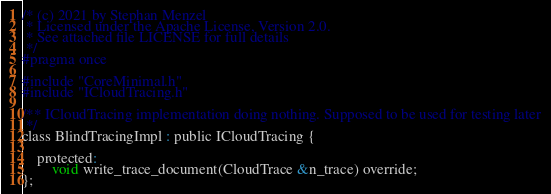Convert code to text. <code><loc_0><loc_0><loc_500><loc_500><_C_>/* (c) 2021 by Stephan Menzel
 * Licensed under the Apache License, Version 2.0.
 * See attached file LICENSE for full details
 */
#pragma once

#include "CoreMinimal.h"
#include "ICloudTracing.h"

/** ICloudTracing implementation doing nothing. Supposed to be used for testing later
 */
class BlindTracingImpl : public ICloudTracing {

	protected:
		void write_trace_document(CloudTrace &n_trace) override;
};
</code> 